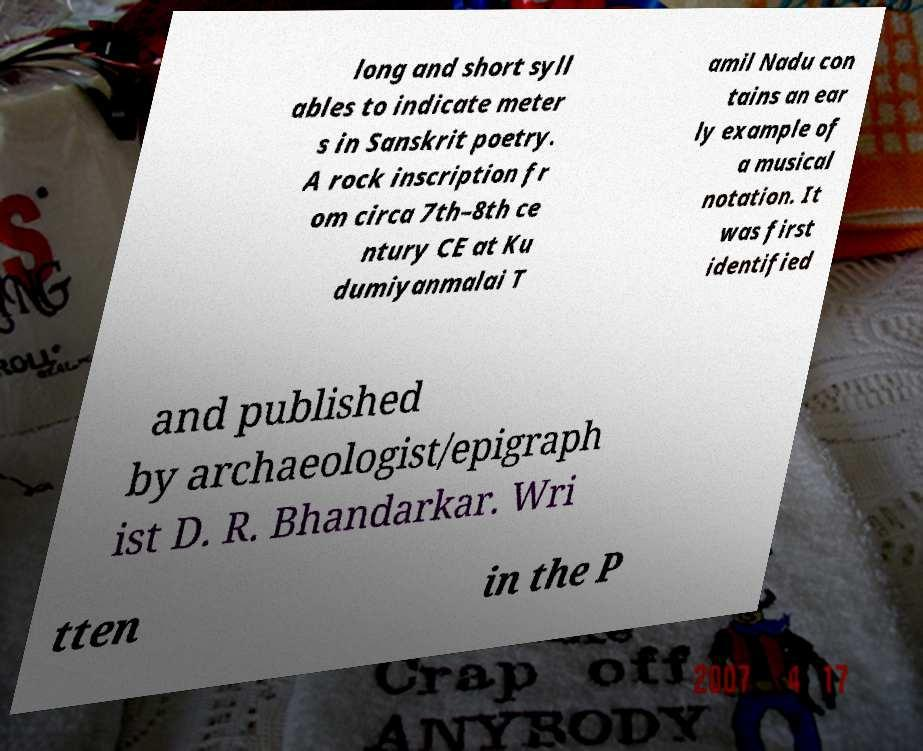I need the written content from this picture converted into text. Can you do that? long and short syll ables to indicate meter s in Sanskrit poetry. A rock inscription fr om circa 7th–8th ce ntury CE at Ku dumiyanmalai T amil Nadu con tains an ear ly example of a musical notation. It was first identified and published by archaeologist/epigraph ist D. R. Bhandarkar. Wri tten in the P 